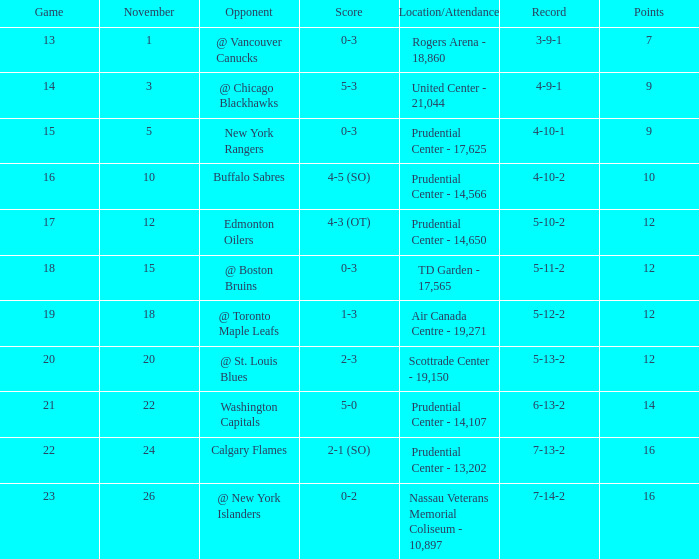Who was the opposition during the game at 14? @ Chicago Blackhawks. 